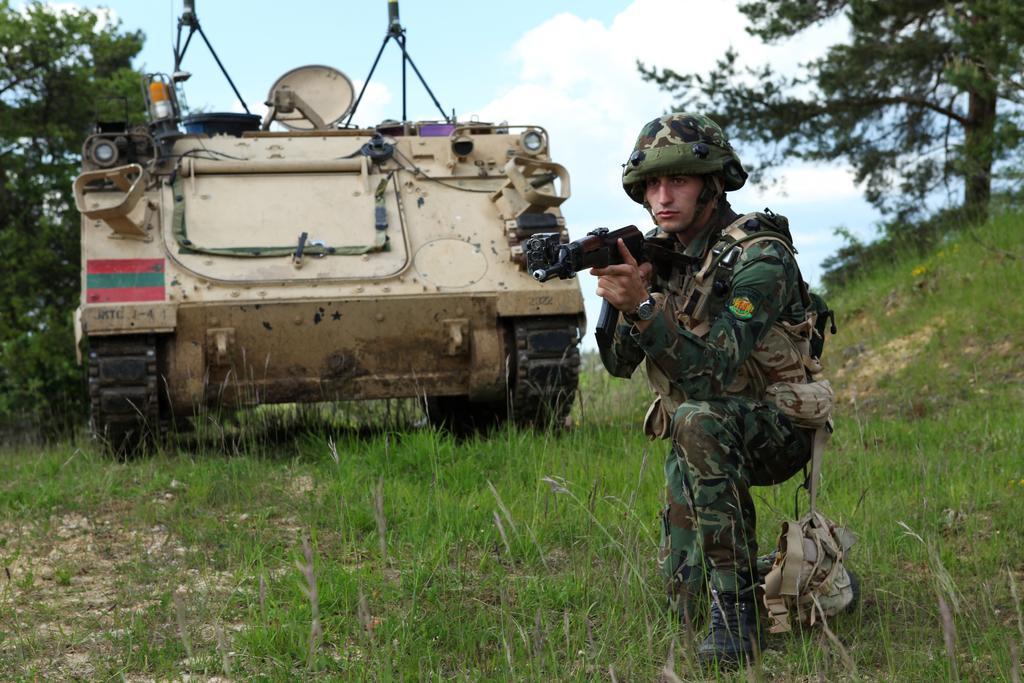Please provide a concise description of this image. In this picture there is a person wearing military dress is crouching and holding a gun in his hands and there is a panzer beside him and there are trees on either sides of him. 